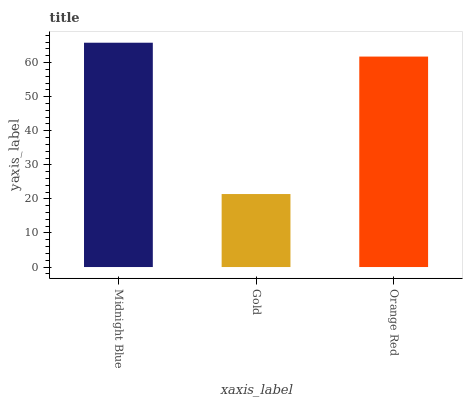Is Orange Red the minimum?
Answer yes or no. No. Is Orange Red the maximum?
Answer yes or no. No. Is Orange Red greater than Gold?
Answer yes or no. Yes. Is Gold less than Orange Red?
Answer yes or no. Yes. Is Gold greater than Orange Red?
Answer yes or no. No. Is Orange Red less than Gold?
Answer yes or no. No. Is Orange Red the high median?
Answer yes or no. Yes. Is Orange Red the low median?
Answer yes or no. Yes. Is Gold the high median?
Answer yes or no. No. Is Gold the low median?
Answer yes or no. No. 